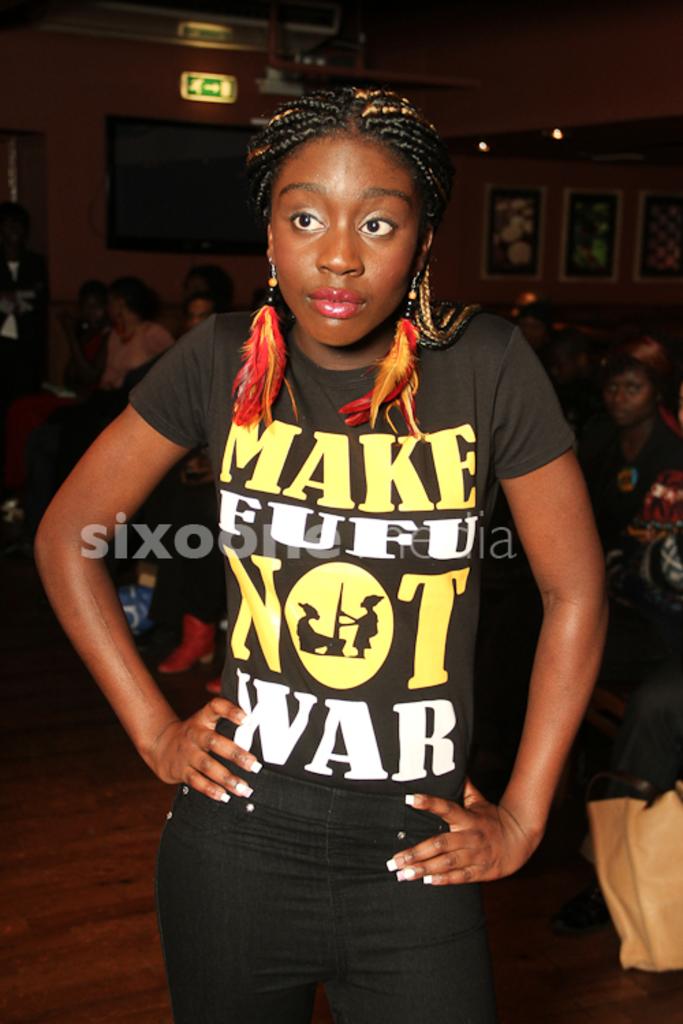What do you make instead of war?
Your response must be concise. Fufu. What is written on the girl's shirt?
Make the answer very short. Make fufu not war. 